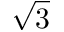<formula> <loc_0><loc_0><loc_500><loc_500>\sqrt { 3 }</formula> 